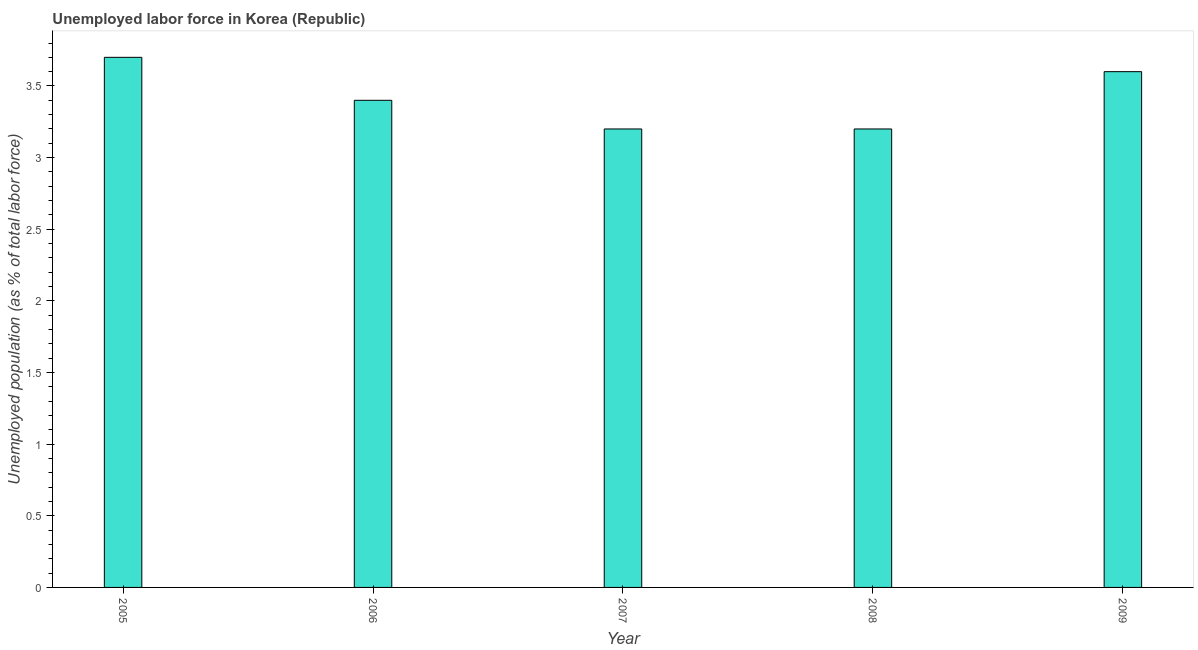Does the graph contain any zero values?
Make the answer very short. No. What is the title of the graph?
Make the answer very short. Unemployed labor force in Korea (Republic). What is the label or title of the X-axis?
Make the answer very short. Year. What is the label or title of the Y-axis?
Ensure brevity in your answer.  Unemployed population (as % of total labor force). What is the total unemployed population in 2005?
Offer a very short reply. 3.7. Across all years, what is the maximum total unemployed population?
Ensure brevity in your answer.  3.7. Across all years, what is the minimum total unemployed population?
Give a very brief answer. 3.2. In which year was the total unemployed population maximum?
Make the answer very short. 2005. What is the sum of the total unemployed population?
Your answer should be compact. 17.1. What is the difference between the total unemployed population in 2006 and 2007?
Your response must be concise. 0.2. What is the average total unemployed population per year?
Offer a very short reply. 3.42. What is the median total unemployed population?
Ensure brevity in your answer.  3.4. In how many years, is the total unemployed population greater than 3.1 %?
Provide a succinct answer. 5. What is the ratio of the total unemployed population in 2008 to that in 2009?
Provide a succinct answer. 0.89. Is the total unemployed population in 2007 less than that in 2008?
Provide a succinct answer. No. How many bars are there?
Offer a terse response. 5. What is the Unemployed population (as % of total labor force) of 2005?
Your response must be concise. 3.7. What is the Unemployed population (as % of total labor force) of 2006?
Offer a very short reply. 3.4. What is the Unemployed population (as % of total labor force) of 2007?
Your answer should be very brief. 3.2. What is the Unemployed population (as % of total labor force) in 2008?
Your answer should be very brief. 3.2. What is the Unemployed population (as % of total labor force) in 2009?
Provide a succinct answer. 3.6. What is the difference between the Unemployed population (as % of total labor force) in 2005 and 2006?
Keep it short and to the point. 0.3. What is the difference between the Unemployed population (as % of total labor force) in 2005 and 2008?
Provide a succinct answer. 0.5. What is the difference between the Unemployed population (as % of total labor force) in 2005 and 2009?
Your response must be concise. 0.1. What is the difference between the Unemployed population (as % of total labor force) in 2006 and 2007?
Provide a succinct answer. 0.2. What is the difference between the Unemployed population (as % of total labor force) in 2006 and 2008?
Make the answer very short. 0.2. What is the difference between the Unemployed population (as % of total labor force) in 2007 and 2008?
Your answer should be compact. 0. What is the difference between the Unemployed population (as % of total labor force) in 2007 and 2009?
Your response must be concise. -0.4. What is the difference between the Unemployed population (as % of total labor force) in 2008 and 2009?
Make the answer very short. -0.4. What is the ratio of the Unemployed population (as % of total labor force) in 2005 to that in 2006?
Ensure brevity in your answer.  1.09. What is the ratio of the Unemployed population (as % of total labor force) in 2005 to that in 2007?
Provide a short and direct response. 1.16. What is the ratio of the Unemployed population (as % of total labor force) in 2005 to that in 2008?
Offer a terse response. 1.16. What is the ratio of the Unemployed population (as % of total labor force) in 2005 to that in 2009?
Your answer should be compact. 1.03. What is the ratio of the Unemployed population (as % of total labor force) in 2006 to that in 2007?
Keep it short and to the point. 1.06. What is the ratio of the Unemployed population (as % of total labor force) in 2006 to that in 2008?
Give a very brief answer. 1.06. What is the ratio of the Unemployed population (as % of total labor force) in 2006 to that in 2009?
Your answer should be very brief. 0.94. What is the ratio of the Unemployed population (as % of total labor force) in 2007 to that in 2008?
Ensure brevity in your answer.  1. What is the ratio of the Unemployed population (as % of total labor force) in 2007 to that in 2009?
Offer a very short reply. 0.89. What is the ratio of the Unemployed population (as % of total labor force) in 2008 to that in 2009?
Your response must be concise. 0.89. 